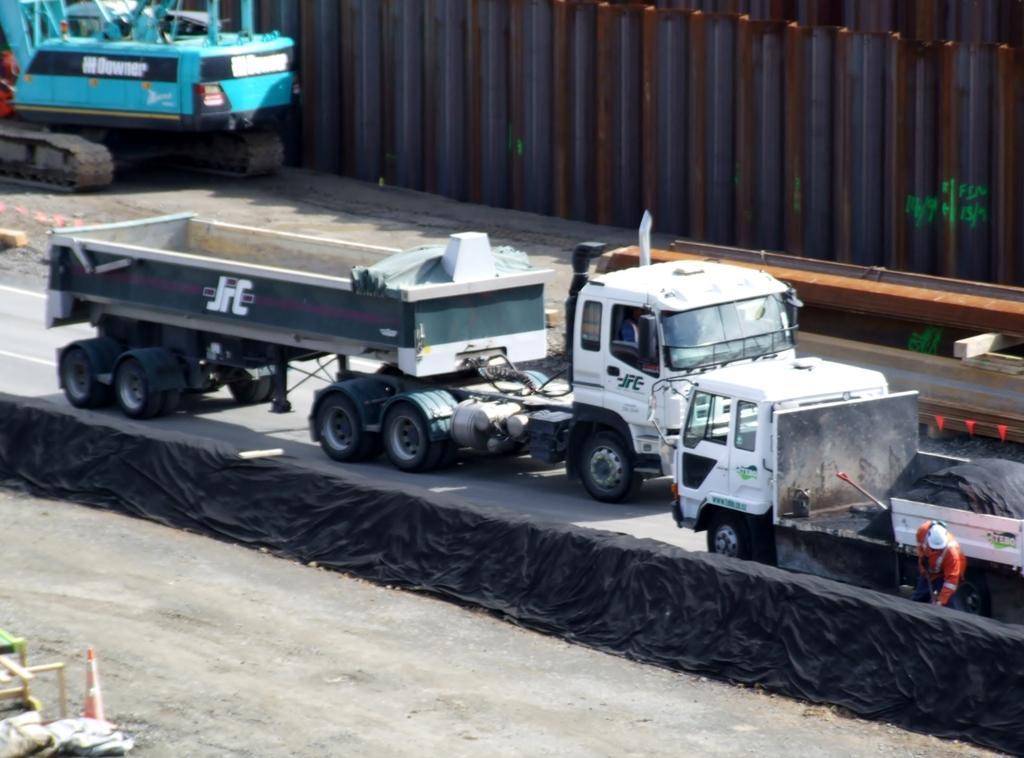In one or two sentences, can you explain what this image depicts? This image is taken outdoors. At the bottom of the image there is ground. There are a few objects on the ground. In the background there is a wall and a crane is parked on the ground. In the middle of the image two trucks and a vehicle are parked on the road and there is a black colored cloth. 